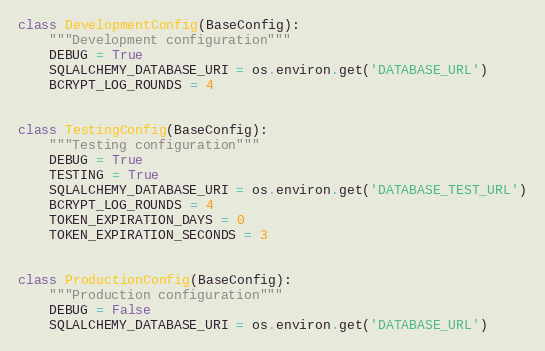Convert code to text. <code><loc_0><loc_0><loc_500><loc_500><_Python_>class DevelopmentConfig(BaseConfig):
    """Development configuration"""
    DEBUG = True
    SQLALCHEMY_DATABASE_URI = os.environ.get('DATABASE_URL')
    BCRYPT_LOG_ROUNDS = 4


class TestingConfig(BaseConfig):
    """Testing configuration"""
    DEBUG = True
    TESTING = True
    SQLALCHEMY_DATABASE_URI = os.environ.get('DATABASE_TEST_URL')
    BCRYPT_LOG_ROUNDS = 4
    TOKEN_EXPIRATION_DAYS = 0
    TOKEN_EXPIRATION_SECONDS = 3


class ProductionConfig(BaseConfig):
    """Production configuration"""
    DEBUG = False
    SQLALCHEMY_DATABASE_URI = os.environ.get('DATABASE_URL')
</code> 